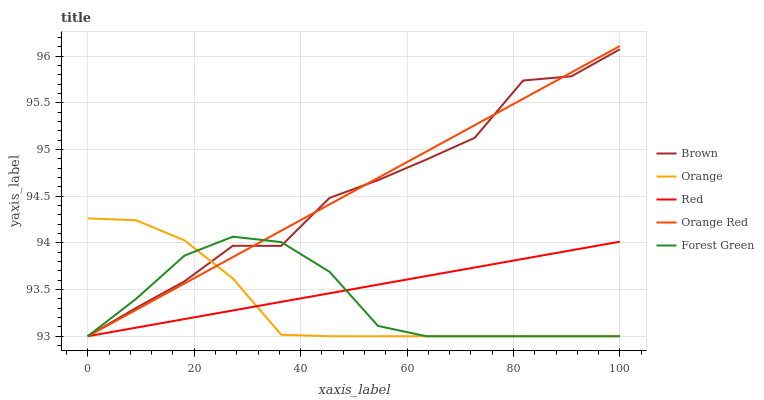Does Orange have the minimum area under the curve?
Answer yes or no. Yes. Does Orange Red have the maximum area under the curve?
Answer yes or no. Yes. Does Brown have the minimum area under the curve?
Answer yes or no. No. Does Brown have the maximum area under the curve?
Answer yes or no. No. Is Red the smoothest?
Answer yes or no. Yes. Is Brown the roughest?
Answer yes or no. Yes. Is Forest Green the smoothest?
Answer yes or no. No. Is Forest Green the roughest?
Answer yes or no. No. Does Orange have the lowest value?
Answer yes or no. Yes. Does Orange Red have the highest value?
Answer yes or no. Yes. Does Brown have the highest value?
Answer yes or no. No. Does Forest Green intersect Orange?
Answer yes or no. Yes. Is Forest Green less than Orange?
Answer yes or no. No. Is Forest Green greater than Orange?
Answer yes or no. No. 